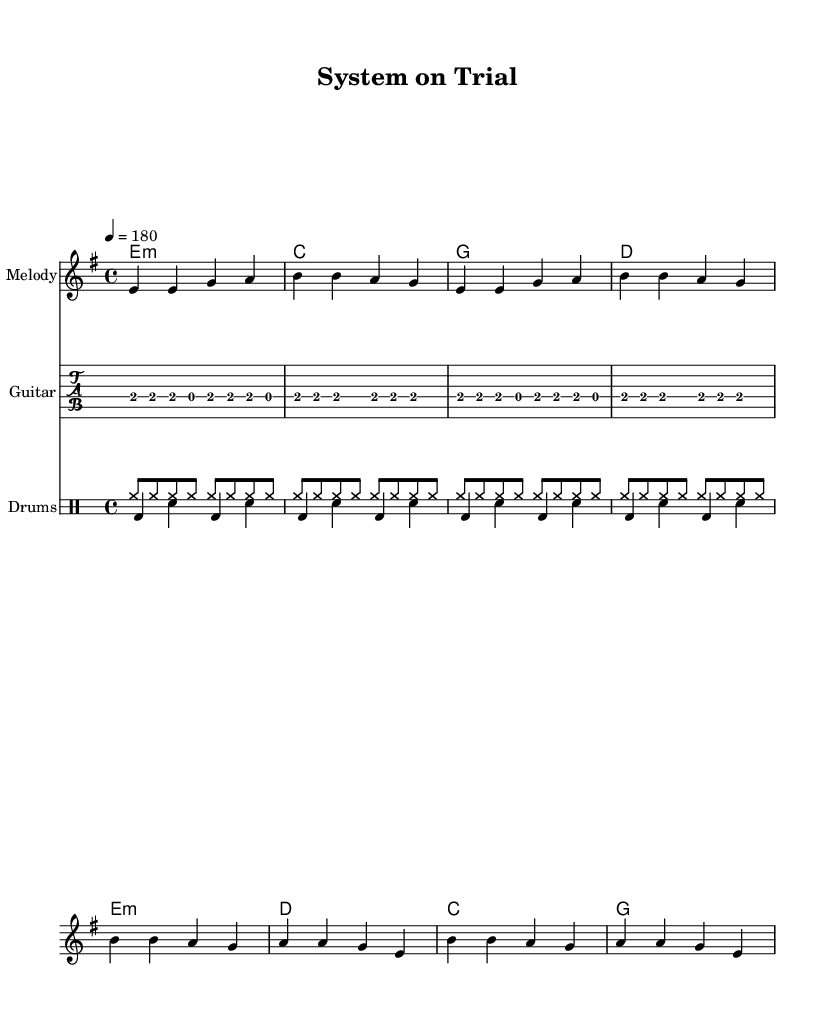What is the key signature of this music? The key signature is E minor, which has one sharp (F#). This can be determined by checking the key signature near the beginning of the sheet music that indicates it is in the E minor key.
Answer: E minor What is the time signature of this piece? The time signature is 4/4, as shown at the start of the music. This indicates that there are four beats in each measure, and the quarter note receives one beat.
Answer: 4/4 What is the tempo marking for this composition? The tempo marking indicates a speed of 180 beats per minute, which is noted in the score as "4 = 180". This means that the quarter note is played at 180 beats each minute.
Answer: 180 What are the chord names used in the verse section? The verse section contains the chords E minor, C, G, and D. These can be found listed in the chord symbols above the melody line corresponding to the verse.
Answer: E minor, C, G, D What is the main theme expressed in the lyrics? The main theme of the lyrics critiques the justice system, suggesting it is corrupt and controlled ("Justice system bought and sold"). This reflects the rebellious nature typical of punk music, focusing on societal issues like injustice.
Answer: Critique of the justice system How many measures are in the chorus section? The chorus section consists of four measures. This can be verified by counting the number of vertical lines indicating bar lines that separate the rhythms in the chorus part of the sheet music.
Answer: Four What type of rhythm pattern is prominent in the drum section? The prominent rhythm pattern in the drum section is a steady eighth-note rhythm in the hi-hat with alternating snare and bass drum hits, demonstrating the aggressive and driving rhythm typical in punk music.
Answer: Eighth-note rhythm 